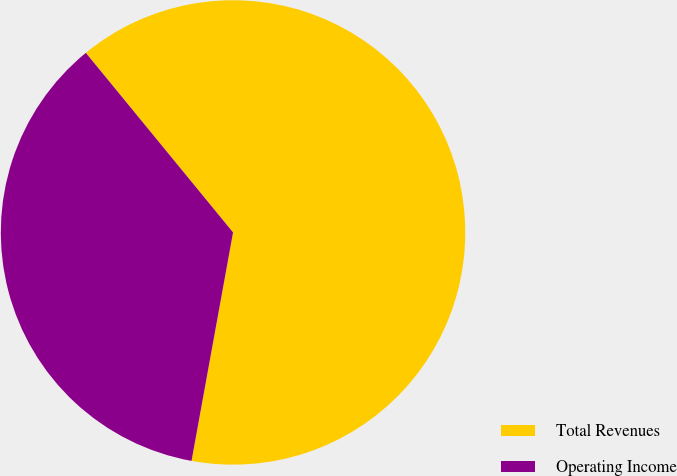Convert chart. <chart><loc_0><loc_0><loc_500><loc_500><pie_chart><fcel>Total Revenues<fcel>Operating Income<nl><fcel>63.79%<fcel>36.21%<nl></chart> 